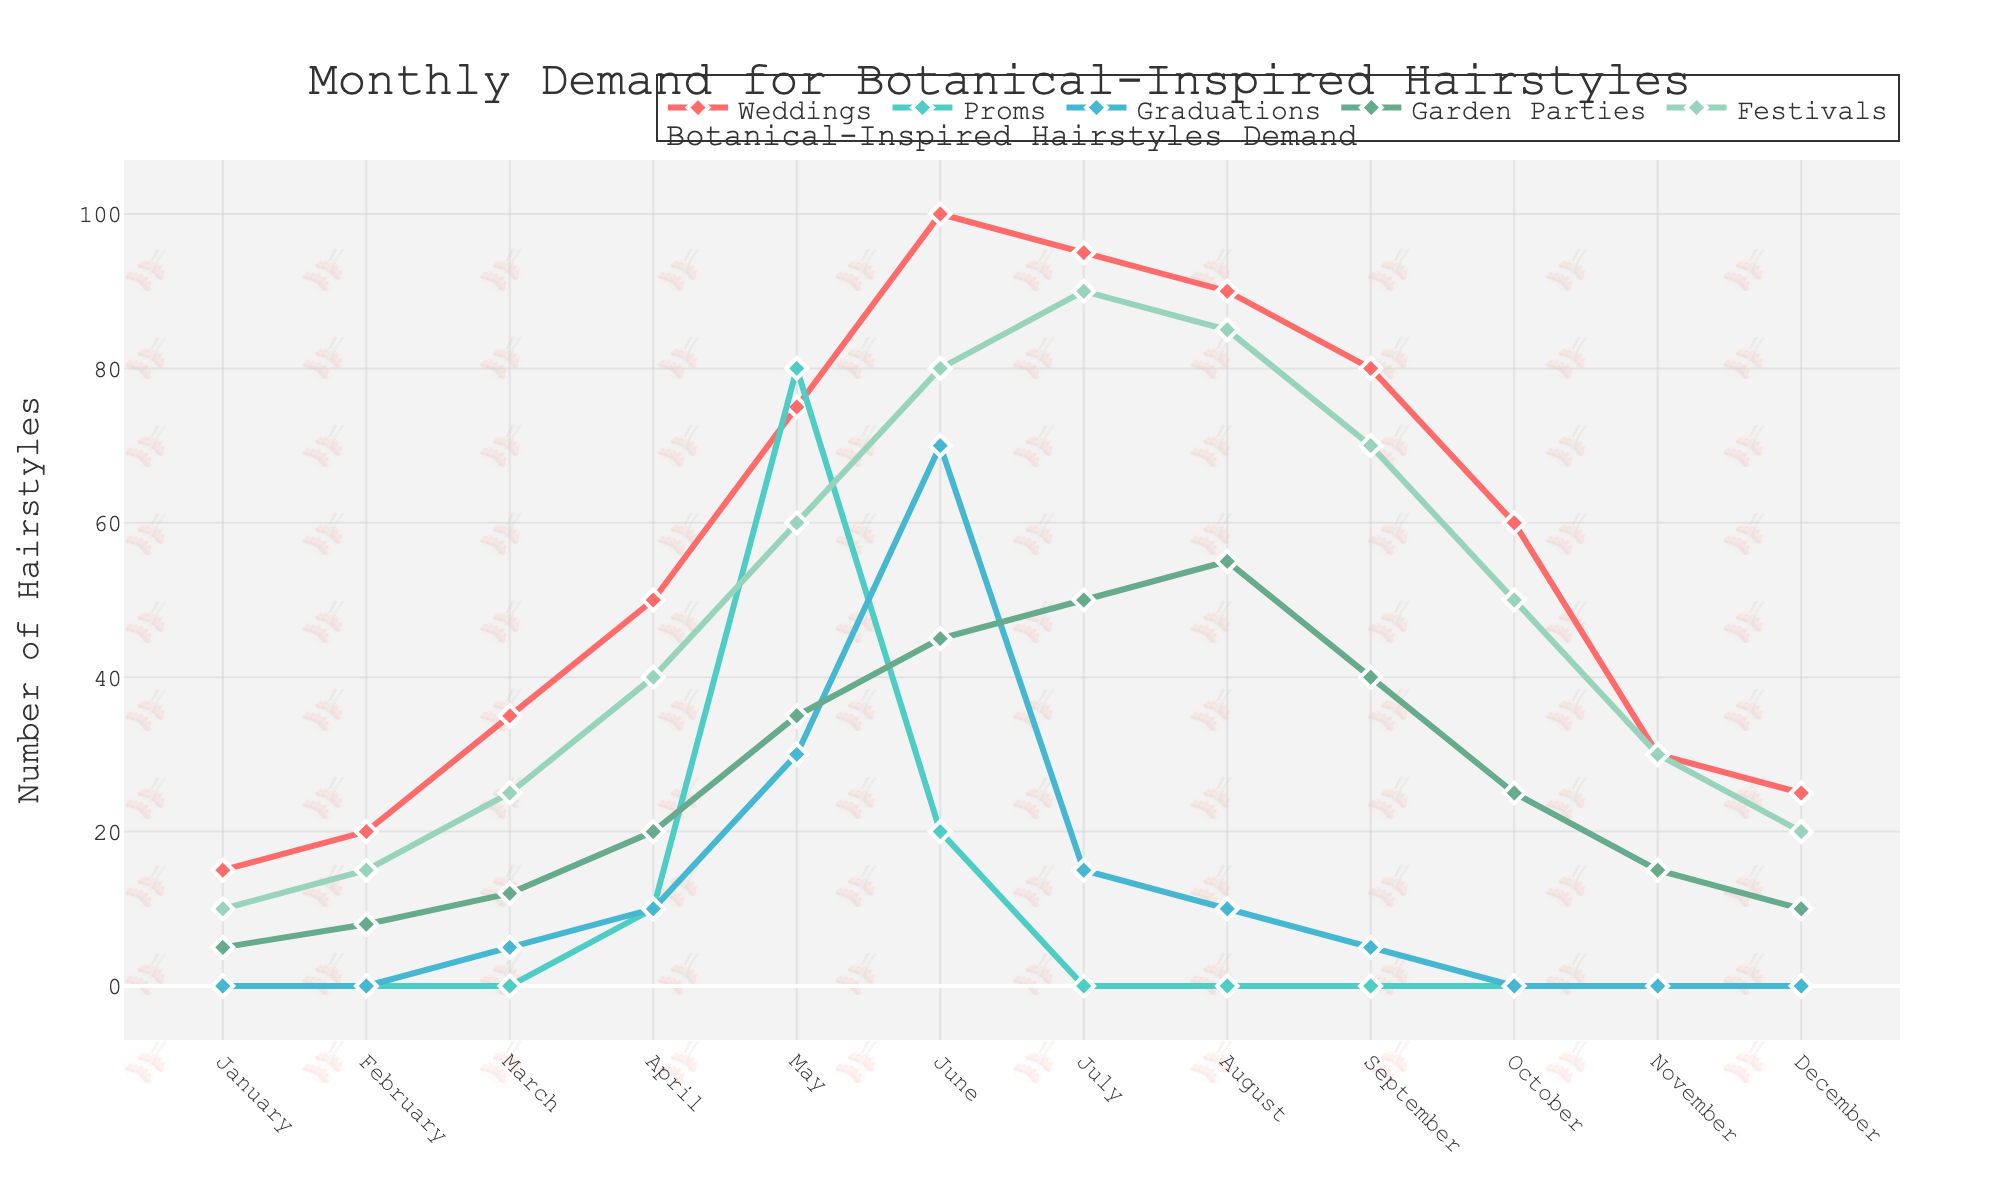What is the month with the highest demand for Weddings? The month with the highest demand for weddings can be identified by finding the peak value in the "Weddings" line on the chart. June has the highest data point at 100.
Answer: June How does the demand for Proms in May compare to the demand for Proms in June? To compare the demand, look at the y-values for Proms in May and June. In May, the demand is 80, while in June, it is 20. 80 is greater than 20.
Answer: Proms in May have a higher demand than in June What is the total demand for Graduations in the first half of the year? To find the total demand for Graduations from January to June, sum the values: 0 (Jan) + 0 (Feb) + 5 (Mar) + 10 (Apr) + 30 (May) + 70 (Jun) = 115.
Answer: 115 Which event type has the lowest demand in July? Examine all the event type lines for the month of July. Proms and Graduations both have a demand of 0.
Answer: Proms and Graduations What is the average monthly demand for Garden Parties in the second half of the year? To find the average, sum the demands for Garden Parties from July to December: 50 (Jul) + 55 (Aug) + 40 (Sep) + 25 (Oct) + 15 (Nov) + 10 (Dec) = 195. Divide by 6 months: 195 / 6 = 32.5.
Answer: 32.5 How does the demand for Festivals in March compare to the demand for Garden Parties in April? Compare the values for the two events. Festivals in March have a demand of 25, and Garden Parties in April have a demand of 20. 25 is greater than 20.
Answer: Festivals have a higher demand than Garden Parties What is the combined demand for all event types in December? Sum the demands for all event types in December: 25 (Weddings) + 0 (Proms) + 0 (Graduations) + 10 (Garden Parties) + 20 (Festivals) = 55.
Answer: 55 Which event type experiences the most consistent demand throughout the year? By visually inspecting the lines, the line with the least fluctuation indicates consistency. Garden Parties have relatively smooth and steady numbers without large spikes.
Answer: Garden Parties What is the difference in demand for Weddings between November and December? Subtract the demand for Weddings in December from November: 30 (Nov) - 25 (Dec) = 5.
Answer: 5 What trend do you observe for Proms throughout the year? By observing the Proms line, it is clear that it only peaks significantly in May and dips to zero for almost every other month.
Answer: Peaks in May and zero for most months 